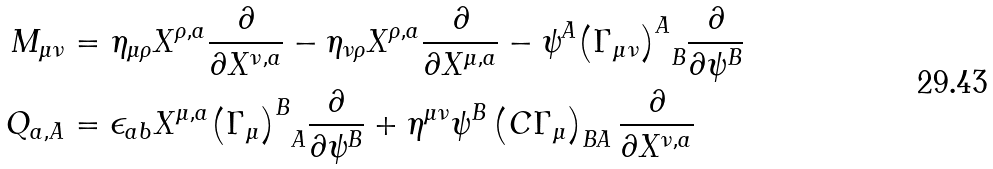<formula> <loc_0><loc_0><loc_500><loc_500>M _ { \mu \nu } & = \eta _ { \mu \rho } X ^ { \rho , a } \frac { \partial } { \partial X ^ { \nu , a } } - \eta _ { \nu \rho } X ^ { \rho , a } \frac { \partial } { \partial X ^ { \mu , a } } - \psi ^ { A } { \left ( \Gamma _ { \mu \nu } \right ) ^ { A } } _ { B } \frac { \partial } { \partial \psi ^ { B } } \\ Q _ { a , A } & = \epsilon _ { a b } X ^ { \mu , a } { \left ( \Gamma _ { \mu } \right ) ^ { B } } _ { A } \frac { \partial } { \partial \psi ^ { B } } + \eta ^ { \mu \nu } \psi ^ { B } \left ( C \Gamma _ { \mu } \right ) _ { B A } \frac { \partial } { \partial X ^ { \nu , a } } \\</formula> 